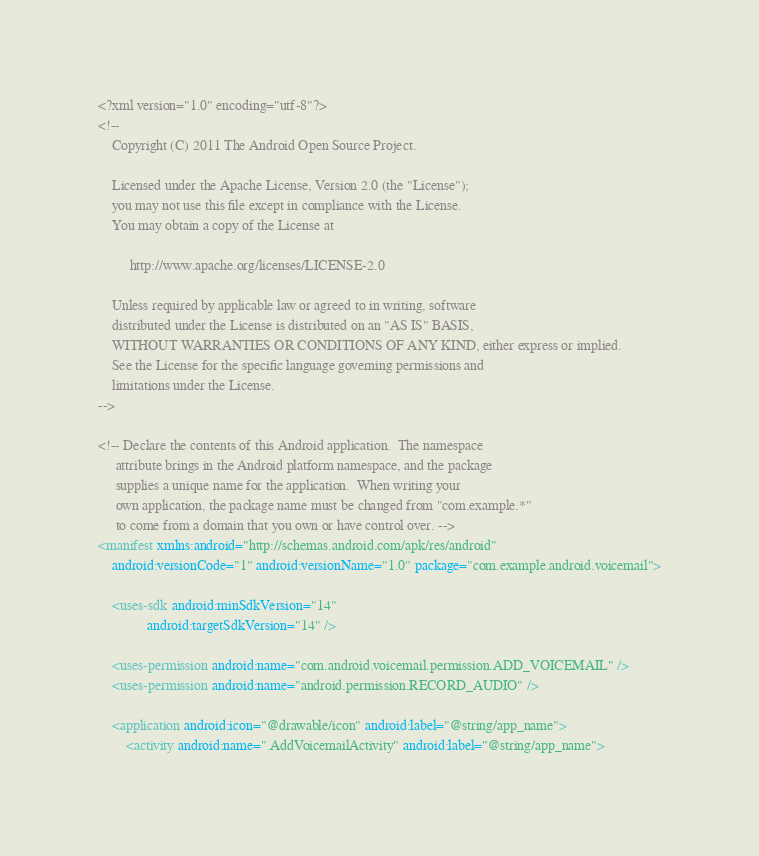Convert code to text. <code><loc_0><loc_0><loc_500><loc_500><_XML_><?xml version="1.0" encoding="utf-8"?>
<!--
    Copyright (C) 2011 The Android Open Source Project.

    Licensed under the Apache License, Version 2.0 (the "License");
    you may not use this file except in compliance with the License.
    You may obtain a copy of the License at

         http://www.apache.org/licenses/LICENSE-2.0

    Unless required by applicable law or agreed to in writing, software
    distributed under the License is distributed on an "AS IS" BASIS,
    WITHOUT WARRANTIES OR CONDITIONS OF ANY KIND, either express or implied.
    See the License for the specific language governing permissions and
    limitations under the License.
-->

<!-- Declare the contents of this Android application.  The namespace
     attribute brings in the Android platform namespace, and the package
     supplies a unique name for the application.  When writing your
     own application, the package name must be changed from "com.example.*"
     to come from a domain that you own or have control over. -->
<manifest xmlns:android="http://schemas.android.com/apk/res/android"
    android:versionCode="1" android:versionName="1.0" package="com.example.android.voicemail">

    <uses-sdk android:minSdkVersion="14"
              android:targetSdkVersion="14" />

    <uses-permission android:name="com.android.voicemail.permission.ADD_VOICEMAIL" />
    <uses-permission android:name="android.permission.RECORD_AUDIO" />

    <application android:icon="@drawable/icon" android:label="@string/app_name">
        <activity android:name=".AddVoicemailActivity" android:label="@string/app_name"></code> 